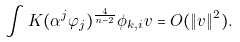<formula> <loc_0><loc_0><loc_500><loc_500>\int K ( \alpha ^ { j } \varphi _ { j } ) ^ { \frac { 4 } { n - 2 } } \phi _ { k , i } v = O ( \| v \| ^ { 2 } ) .</formula> 